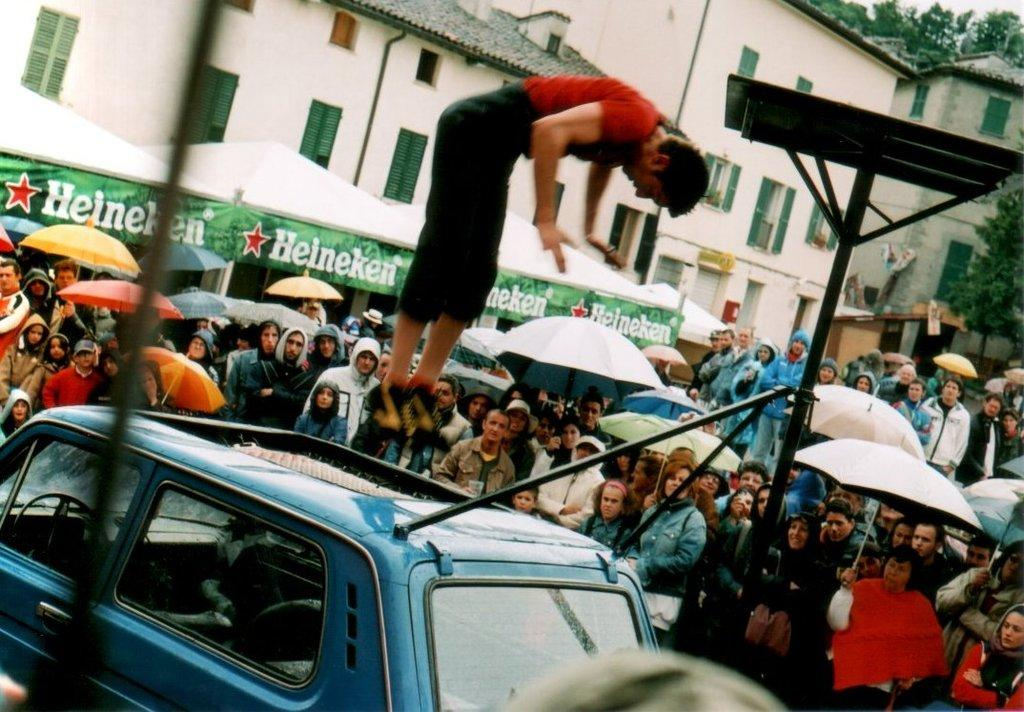<image>
Provide a brief description of the given image. A man is doing a front flip on a car in front of tents that have "Heineken" banners. 